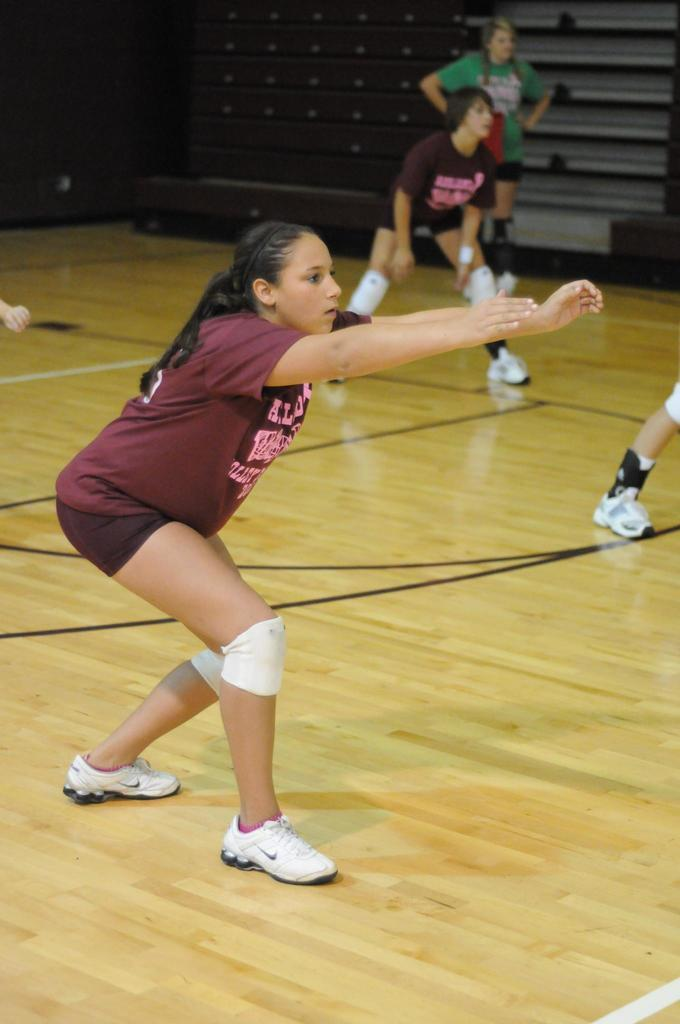What are the people in the image doing? The people in the image are standing. Where are the people standing in the image? The people are standing on the floor. What can be seen in the background of the image? There appears to be a cupboard in the background of the image. How many trees are visible in the image? There are no trees visible in the image; it features people standing on the floor with a cupboard in the background. 